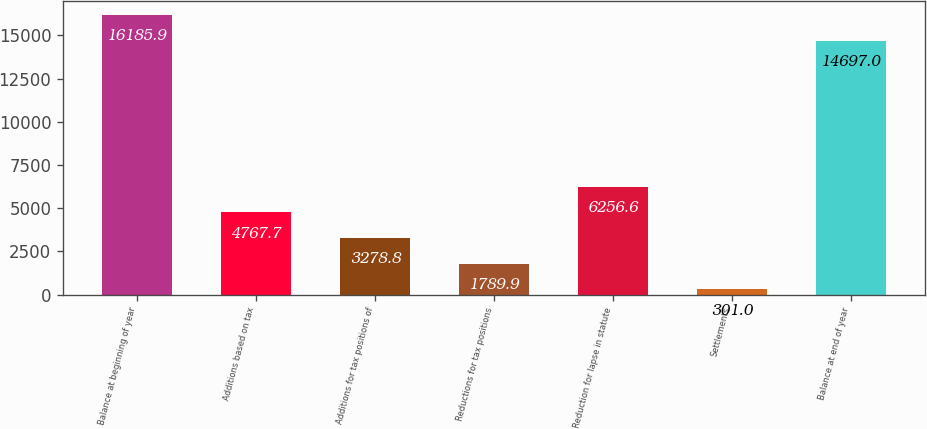<chart> <loc_0><loc_0><loc_500><loc_500><bar_chart><fcel>Balance at beginning of year<fcel>Additions based on tax<fcel>Additions for tax positions of<fcel>Reductions for tax positions<fcel>Reduction for lapse in statute<fcel>Settlements<fcel>Balance at end of year<nl><fcel>16185.9<fcel>4767.7<fcel>3278.8<fcel>1789.9<fcel>6256.6<fcel>301<fcel>14697<nl></chart> 